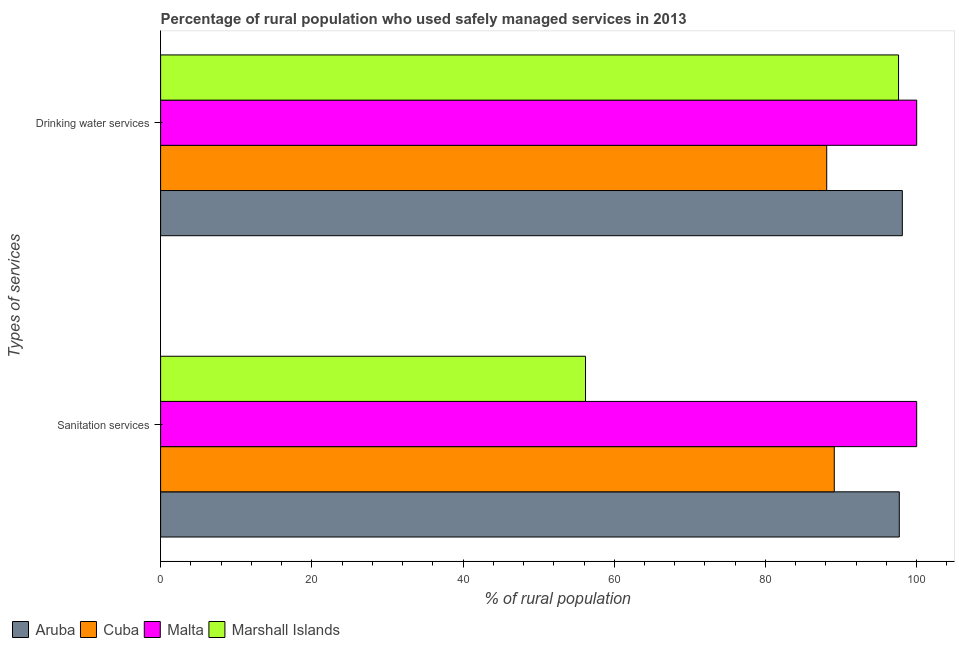Are the number of bars per tick equal to the number of legend labels?
Your response must be concise. Yes. Are the number of bars on each tick of the Y-axis equal?
Your answer should be very brief. Yes. How many bars are there on the 1st tick from the bottom?
Make the answer very short. 4. What is the label of the 2nd group of bars from the top?
Give a very brief answer. Sanitation services. What is the percentage of rural population who used sanitation services in Cuba?
Provide a succinct answer. 89.1. Across all countries, what is the minimum percentage of rural population who used sanitation services?
Your response must be concise. 56.2. In which country was the percentage of rural population who used sanitation services maximum?
Make the answer very short. Malta. In which country was the percentage of rural population who used drinking water services minimum?
Provide a succinct answer. Cuba. What is the total percentage of rural population who used drinking water services in the graph?
Make the answer very short. 383.8. What is the difference between the percentage of rural population who used drinking water services in Marshall Islands and that in Malta?
Make the answer very short. -2.4. What is the difference between the percentage of rural population who used drinking water services in Cuba and the percentage of rural population who used sanitation services in Malta?
Keep it short and to the point. -11.9. What is the average percentage of rural population who used sanitation services per country?
Offer a terse response. 85.75. What is the ratio of the percentage of rural population who used sanitation services in Aruba to that in Marshall Islands?
Provide a short and direct response. 1.74. In how many countries, is the percentage of rural population who used sanitation services greater than the average percentage of rural population who used sanitation services taken over all countries?
Provide a succinct answer. 3. What does the 1st bar from the top in Sanitation services represents?
Keep it short and to the point. Marshall Islands. What does the 4th bar from the bottom in Sanitation services represents?
Give a very brief answer. Marshall Islands. Are all the bars in the graph horizontal?
Offer a very short reply. Yes. Does the graph contain any zero values?
Offer a terse response. No. Does the graph contain grids?
Ensure brevity in your answer.  No. Where does the legend appear in the graph?
Your answer should be compact. Bottom left. How many legend labels are there?
Keep it short and to the point. 4. What is the title of the graph?
Keep it short and to the point. Percentage of rural population who used safely managed services in 2013. What is the label or title of the X-axis?
Offer a terse response. % of rural population. What is the label or title of the Y-axis?
Provide a short and direct response. Types of services. What is the % of rural population in Aruba in Sanitation services?
Offer a very short reply. 97.7. What is the % of rural population in Cuba in Sanitation services?
Ensure brevity in your answer.  89.1. What is the % of rural population of Malta in Sanitation services?
Your response must be concise. 100. What is the % of rural population in Marshall Islands in Sanitation services?
Your answer should be compact. 56.2. What is the % of rural population of Aruba in Drinking water services?
Offer a terse response. 98.1. What is the % of rural population of Cuba in Drinking water services?
Ensure brevity in your answer.  88.1. What is the % of rural population of Marshall Islands in Drinking water services?
Offer a terse response. 97.6. Across all Types of services, what is the maximum % of rural population in Aruba?
Provide a succinct answer. 98.1. Across all Types of services, what is the maximum % of rural population of Cuba?
Your response must be concise. 89.1. Across all Types of services, what is the maximum % of rural population of Malta?
Your answer should be compact. 100. Across all Types of services, what is the maximum % of rural population of Marshall Islands?
Ensure brevity in your answer.  97.6. Across all Types of services, what is the minimum % of rural population in Aruba?
Provide a short and direct response. 97.7. Across all Types of services, what is the minimum % of rural population in Cuba?
Offer a terse response. 88.1. Across all Types of services, what is the minimum % of rural population in Marshall Islands?
Provide a succinct answer. 56.2. What is the total % of rural population of Aruba in the graph?
Make the answer very short. 195.8. What is the total % of rural population in Cuba in the graph?
Your answer should be compact. 177.2. What is the total % of rural population in Marshall Islands in the graph?
Offer a terse response. 153.8. What is the difference between the % of rural population of Marshall Islands in Sanitation services and that in Drinking water services?
Keep it short and to the point. -41.4. What is the difference between the % of rural population in Aruba in Sanitation services and the % of rural population in Cuba in Drinking water services?
Make the answer very short. 9.6. What is the difference between the % of rural population of Aruba in Sanitation services and the % of rural population of Marshall Islands in Drinking water services?
Offer a very short reply. 0.1. What is the difference between the % of rural population in Cuba in Sanitation services and the % of rural population in Malta in Drinking water services?
Keep it short and to the point. -10.9. What is the difference between the % of rural population in Malta in Sanitation services and the % of rural population in Marshall Islands in Drinking water services?
Offer a terse response. 2.4. What is the average % of rural population of Aruba per Types of services?
Provide a short and direct response. 97.9. What is the average % of rural population in Cuba per Types of services?
Your answer should be compact. 88.6. What is the average % of rural population in Malta per Types of services?
Make the answer very short. 100. What is the average % of rural population of Marshall Islands per Types of services?
Make the answer very short. 76.9. What is the difference between the % of rural population in Aruba and % of rural population in Cuba in Sanitation services?
Offer a terse response. 8.6. What is the difference between the % of rural population of Aruba and % of rural population of Malta in Sanitation services?
Offer a very short reply. -2.3. What is the difference between the % of rural population of Aruba and % of rural population of Marshall Islands in Sanitation services?
Provide a short and direct response. 41.5. What is the difference between the % of rural population in Cuba and % of rural population in Malta in Sanitation services?
Provide a short and direct response. -10.9. What is the difference between the % of rural population of Cuba and % of rural population of Marshall Islands in Sanitation services?
Your answer should be very brief. 32.9. What is the difference between the % of rural population in Malta and % of rural population in Marshall Islands in Sanitation services?
Provide a succinct answer. 43.8. What is the difference between the % of rural population in Aruba and % of rural population in Cuba in Drinking water services?
Your answer should be compact. 10. What is the difference between the % of rural population in Aruba and % of rural population in Malta in Drinking water services?
Offer a terse response. -1.9. What is the difference between the % of rural population in Cuba and % of rural population in Marshall Islands in Drinking water services?
Offer a very short reply. -9.5. What is the difference between the % of rural population of Malta and % of rural population of Marshall Islands in Drinking water services?
Offer a very short reply. 2.4. What is the ratio of the % of rural population in Aruba in Sanitation services to that in Drinking water services?
Your answer should be very brief. 1. What is the ratio of the % of rural population of Cuba in Sanitation services to that in Drinking water services?
Give a very brief answer. 1.01. What is the ratio of the % of rural population in Marshall Islands in Sanitation services to that in Drinking water services?
Your answer should be compact. 0.58. What is the difference between the highest and the second highest % of rural population in Malta?
Give a very brief answer. 0. What is the difference between the highest and the second highest % of rural population in Marshall Islands?
Offer a very short reply. 41.4. What is the difference between the highest and the lowest % of rural population of Malta?
Offer a terse response. 0. What is the difference between the highest and the lowest % of rural population in Marshall Islands?
Provide a succinct answer. 41.4. 